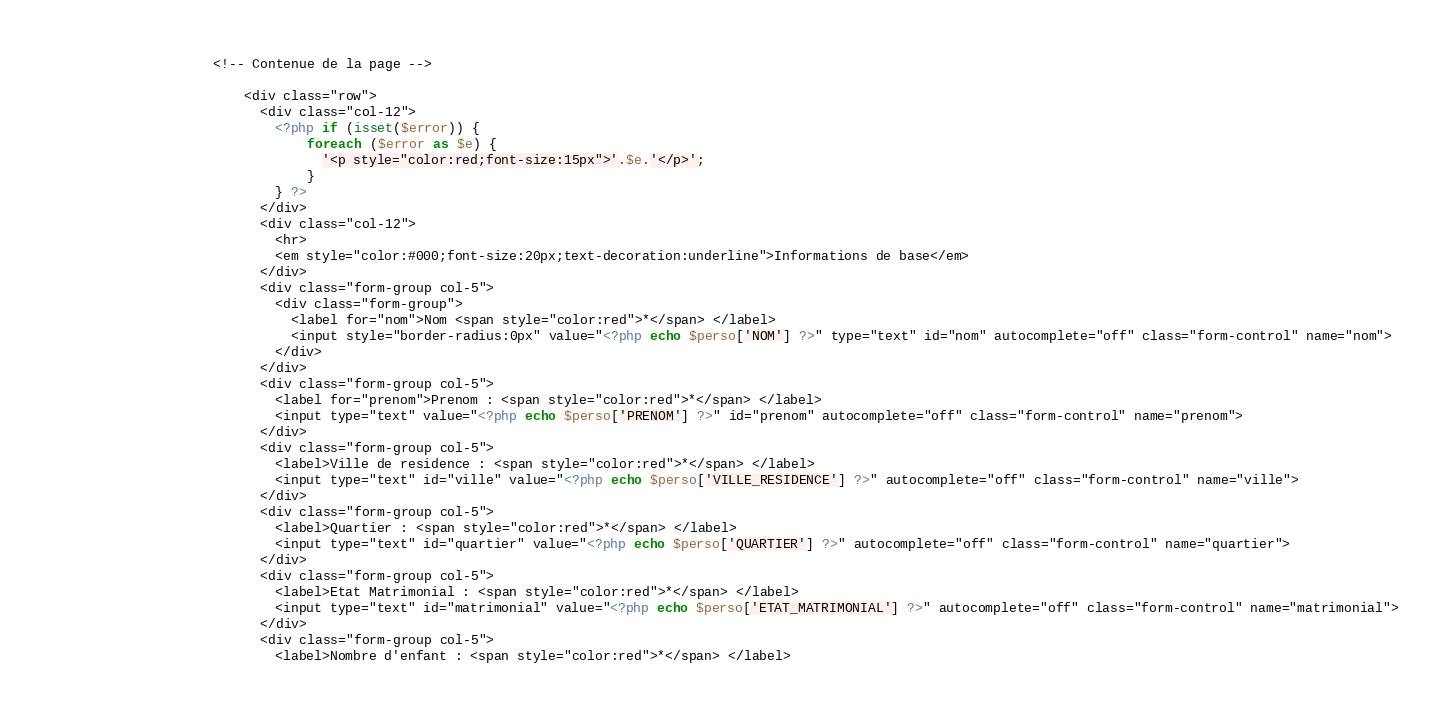Convert code to text. <code><loc_0><loc_0><loc_500><loc_500><_PHP_>                    <!-- Contenue de la page -->

                        <div class="row">
                          <div class="col-12">
                            <?php if (isset($error)) {
                                foreach ($error as $e) {
                                  '<p style="color:red;font-size:15px">'.$e.'</p>';
                                }
                            } ?>
                          </div>
                          <div class="col-12">
                            <hr>
                            <em style="color:#000;font-size:20px;text-decoration:underline">Informations de base</em>
                          </div>
                          <div class="form-group col-5">
                            <div class="form-group">
                              <label for="nom">Nom <span style="color:red">*</span> </label>
                              <input style="border-radius:0px" value="<?php echo $perso['NOM'] ?>" type="text" id="nom" autocomplete="off" class="form-control" name="nom">
                            </div>
                          </div>
                          <div class="form-group col-5">
                            <label for="prenom">Prenom : <span style="color:red">*</span> </label>
                            <input type="text" value="<?php echo $perso['PRENOM'] ?>" id="prenom" autocomplete="off" class="form-control" name="prenom">
                          </div>
                          <div class="form-group col-5">
                            <label>Ville de residence : <span style="color:red">*</span> </label>
                            <input type="text" id="ville" value="<?php echo $perso['VILLE_RESIDENCE'] ?>" autocomplete="off" class="form-control" name="ville">
                          </div>
                          <div class="form-group col-5">
                            <label>Quartier : <span style="color:red">*</span> </label>
                            <input type="text" id="quartier" value="<?php echo $perso['QUARTIER'] ?>" autocomplete="off" class="form-control" name="quartier">
                          </div>
                          <div class="form-group col-5">
                            <label>Etat Matrimonial : <span style="color:red">*</span> </label>
                            <input type="text" id="matrimonial" value="<?php echo $perso['ETAT_MATRIMONIAL'] ?>" autocomplete="off" class="form-control" name="matrimonial">
                          </div>
                          <div class="form-group col-5">
                            <label>Nombre d'enfant : <span style="color:red">*</span> </label></code> 